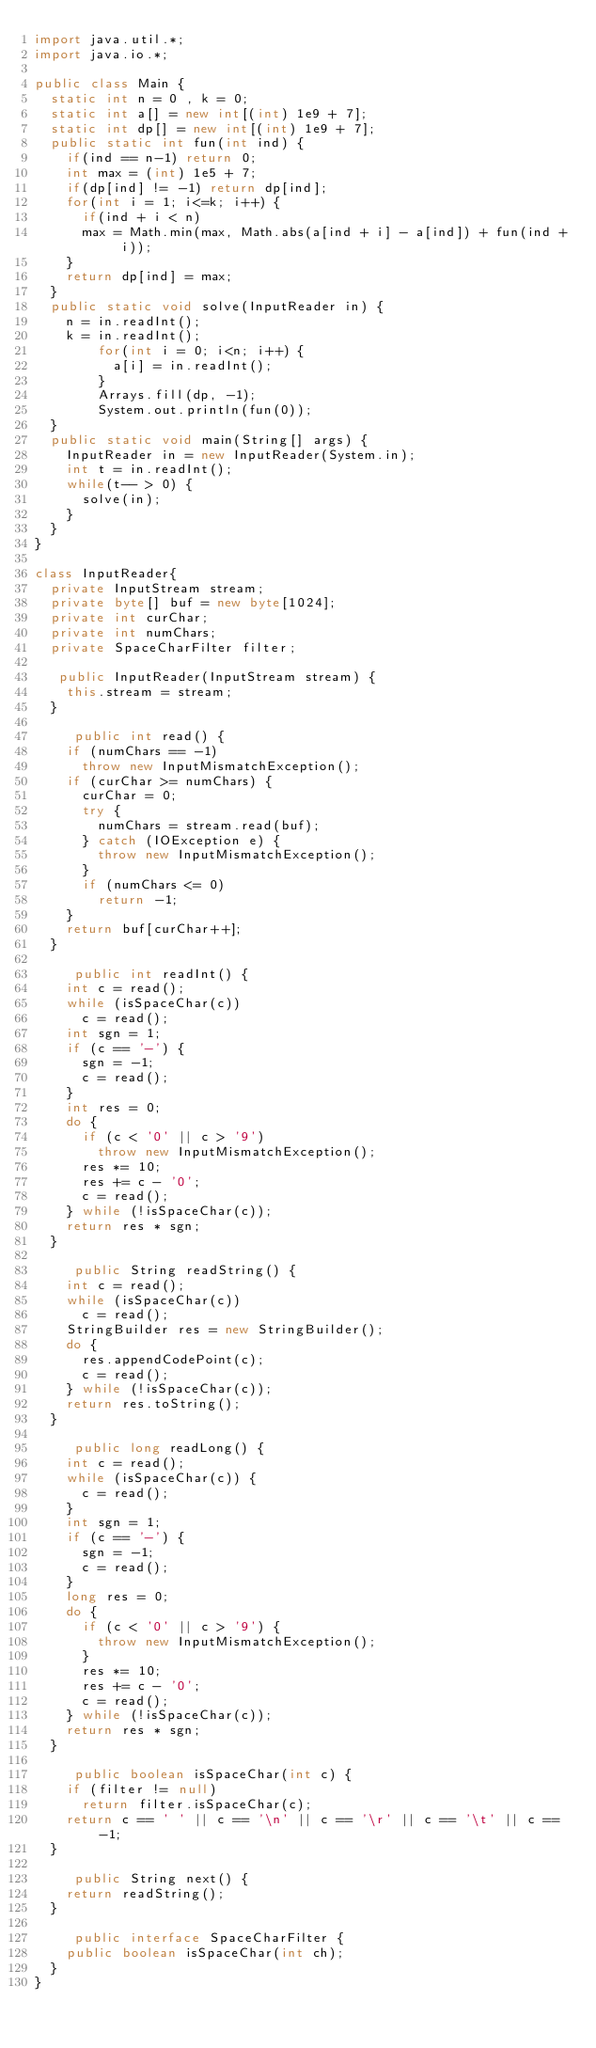Convert code to text. <code><loc_0><loc_0><loc_500><loc_500><_Java_>import java.util.*; 
import java.io.*;

public class Main {
	static int n = 0 , k = 0; 
	static int a[] = new int[(int) 1e9 + 7];
	static int dp[] = new int[(int) 1e9 + 7]; 
	public static int fun(int ind) {
		if(ind == n-1) return 0; 
		int max = (int) 1e5 + 7; 
		if(dp[ind] != -1) return dp[ind]; 
		for(int i = 1; i<=k; i++) {
			if(ind + i < n)
			max = Math.min(max, Math.abs(a[ind + i] - a[ind]) + fun(ind + i)); 
		}
		return dp[ind] = max; 
	}
	public static void solve(InputReader in) {
		n = in.readInt(); 
		k = in.readInt(); 
        for(int i = 0; i<n; i++) {
        	a[i] = in.readInt(); 
        }
        Arrays.fill(dp, -1); 
        System.out.println(fun(0)); 
	}
	public static void main(String[] args) {
		InputReader in = new InputReader(System.in); 
		int t = in.readInt(); 
		while(t-- > 0) {
			solve(in); 
		}
	}
}

class InputReader{
	private InputStream stream;
	private byte[] buf = new byte[1024];
	private int curChar;
	private int numChars;
	private SpaceCharFilter filter;

	 public InputReader(InputStream stream) {
		this.stream = stream;
	}

     public int read() {
		if (numChars == -1)
			throw new InputMismatchException();
		if (curChar >= numChars) {
			curChar = 0;
			try {
				numChars = stream.read(buf);
			} catch (IOException e) {
				throw new InputMismatchException();
			}
			if (numChars <= 0)
				return -1;
		}
		return buf[curChar++];
	}

     public int readInt() {
		int c = read();
		while (isSpaceChar(c))
			c = read();
		int sgn = 1;
		if (c == '-') {
			sgn = -1;
			c = read();
		}
		int res = 0;
		do {
			if (c < '0' || c > '9')
				throw new InputMismatchException();
			res *= 10;
			res += c - '0';
			c = read();
		} while (!isSpaceChar(c));
		return res * sgn;
	}

     public String readString() {
		int c = read();
		while (isSpaceChar(c))
			c = read();
		StringBuilder res = new StringBuilder();
		do {
			res.appendCodePoint(c);
			c = read();
		} while (!isSpaceChar(c));
		return res.toString();
	}

     public long readLong() {
		int c = read();
		while (isSpaceChar(c)) {
			c = read();
		}
		int sgn = 1;
		if (c == '-') {
			sgn = -1;
			c = read();
		}
		long res = 0;
		do {
			if (c < '0' || c > '9') {
				throw new InputMismatchException();
			}
			res *= 10;
			res += c - '0';
			c = read();
		} while (!isSpaceChar(c));
		return res * sgn;
	}
	
     public boolean isSpaceChar(int c) {
		if (filter != null)
			return filter.isSpaceChar(c);
		return c == ' ' || c == '\n' || c == '\r' || c == '\t' || c == -1;
	}
     
     public String next() {
		return readString();
	}
    
     public interface SpaceCharFilter {
		public boolean isSpaceChar(int ch);
	}
}
</code> 